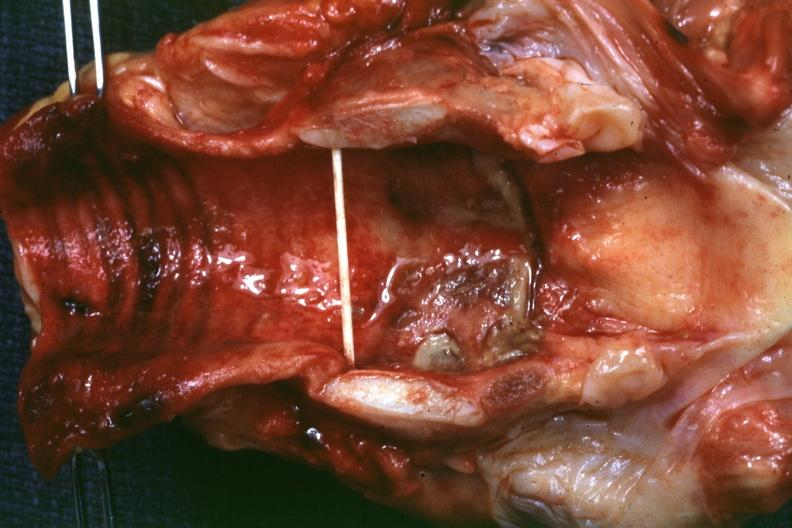what is present?
Answer the question using a single word or phrase. Ulcer due to tube 